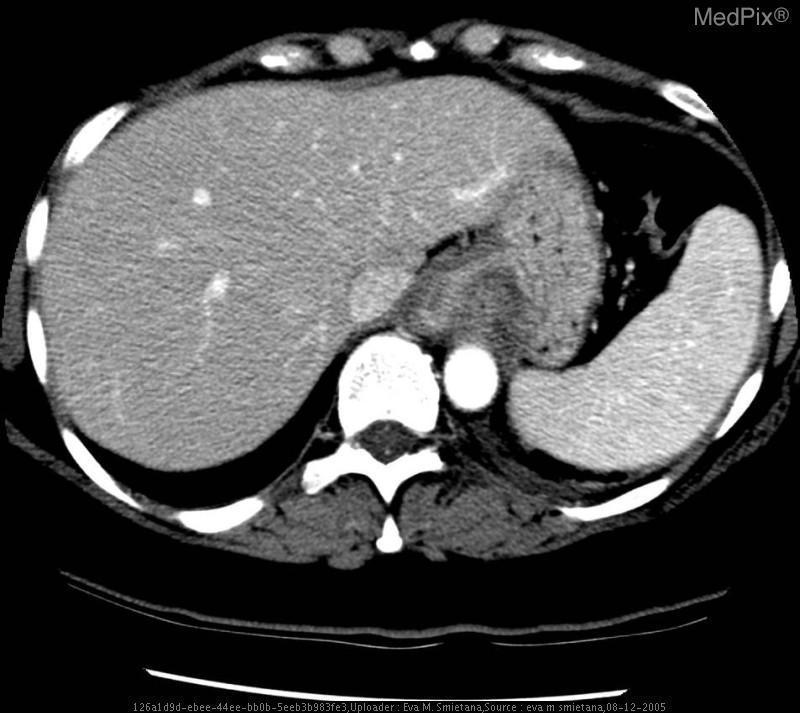Is the mass heterogeneous or homogeneous in appearance?
Write a very short answer. Heterogeneous. Are the liver 	splee n	stomac h	and esophagus all visualized in this image?
Write a very short answer. Yes. Is the mass compressing the inferior vena cava?
Keep it brief. No. Is the inferior vena cava compressed by the tumor?
Write a very short answer. No. Was the arterial contrast phase selected?
Short answer required. Yes. Does this plane of section include the gastric cardia?
Quick response, please. Yes. Is there evidence of portal venous congestion?
Quick response, please. No. Is the portal vein engorged?
Concise answer only. No. Is there evidence of ectopic tissue present in surrounding organs?
Keep it brief. No. Is there evidence of metastatic tissue on organs surrounding the liver?
Answer briefly. No. 